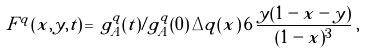Convert formula to latex. <formula><loc_0><loc_0><loc_500><loc_500>\tilde { F } ^ { q } ( \tilde { x } , y , t ) \, = \, g _ { A } ^ { q } ( t ) / g _ { A } ^ { q } ( 0 ) \, \Delta q ( \tilde { x } ) \, 6 \, { \frac { y ( 1 - \tilde { x } - y ) } { ( 1 - \tilde { x } ) ^ { 3 } } } \, ,</formula> 